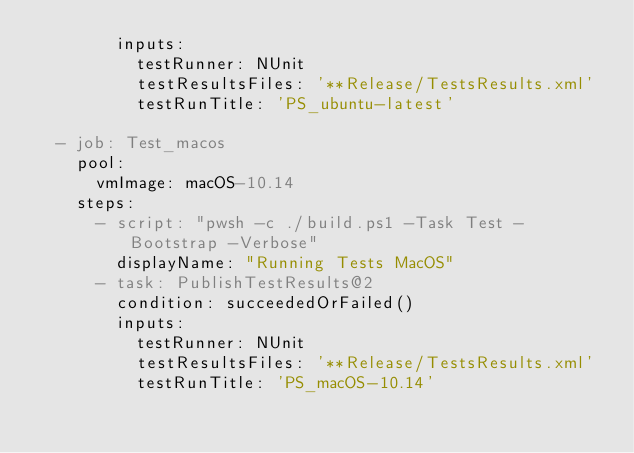Convert code to text. <code><loc_0><loc_0><loc_500><loc_500><_YAML_>        inputs:
          testRunner: NUnit
          testResultsFiles: '**Release/TestsResults.xml'
          testRunTitle: 'PS_ubuntu-latest'

  - job: Test_macos
    pool: 
      vmImage: macOS-10.14
    steps: 
      - script: "pwsh -c ./build.ps1 -Task Test -Bootstrap -Verbose"
        displayName: "Running Tests MacOS"
      - task: PublishTestResults@2
        condition: succeededOrFailed()
        inputs:
          testRunner: NUnit
          testResultsFiles: '**Release/TestsResults.xml'
          testRunTitle: 'PS_macOS-10.14'</code> 